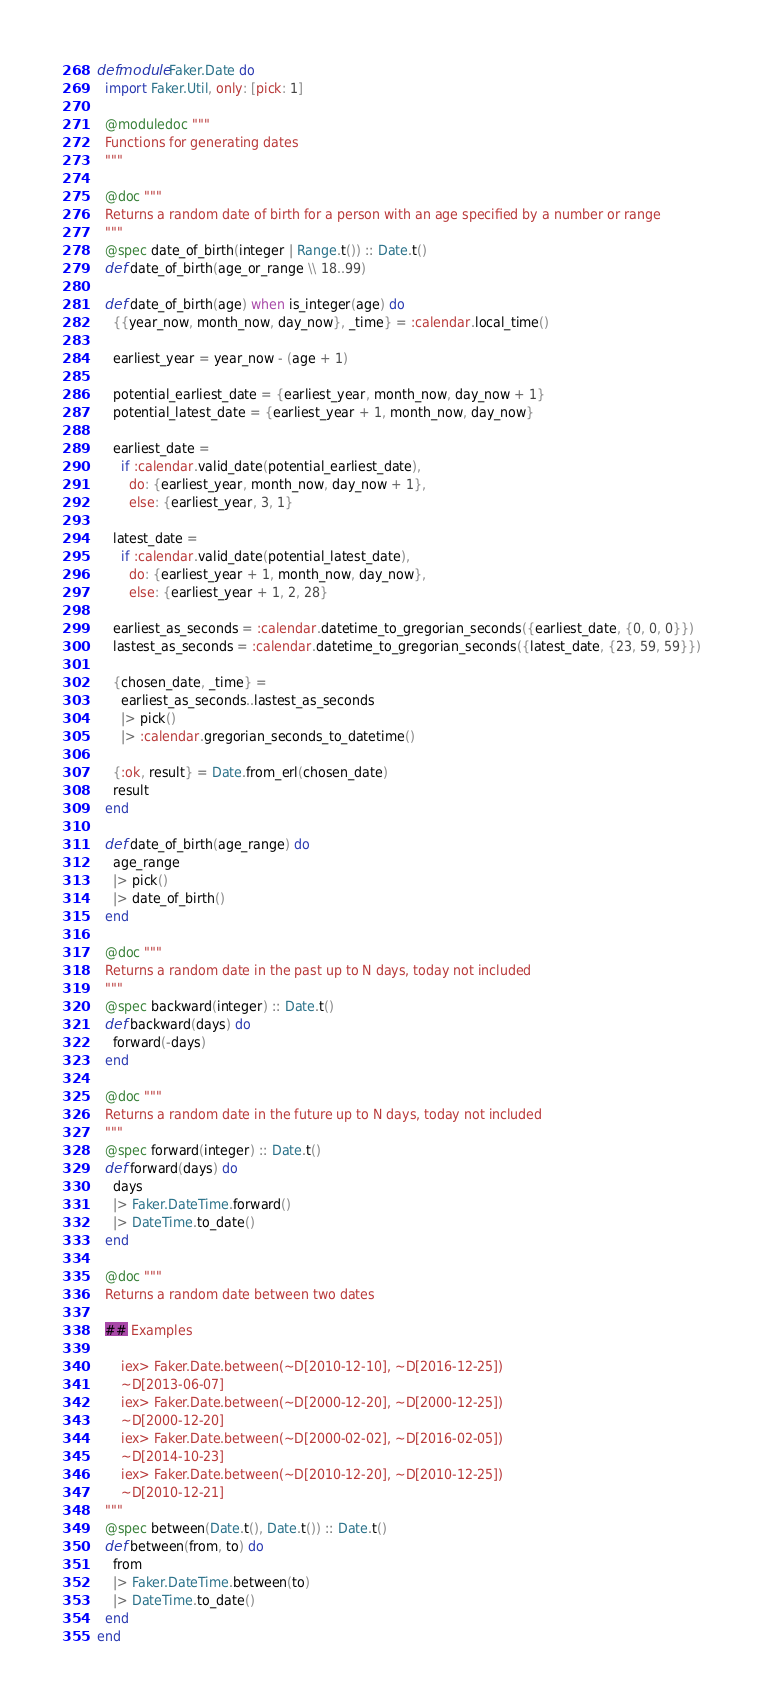Convert code to text. <code><loc_0><loc_0><loc_500><loc_500><_Elixir_>defmodule Faker.Date do
  import Faker.Util, only: [pick: 1]

  @moduledoc """
  Functions for generating dates
  """

  @doc """
  Returns a random date of birth for a person with an age specified by a number or range
  """
  @spec date_of_birth(integer | Range.t()) :: Date.t()
  def date_of_birth(age_or_range \\ 18..99)

  def date_of_birth(age) when is_integer(age) do
    {{year_now, month_now, day_now}, _time} = :calendar.local_time()

    earliest_year = year_now - (age + 1)

    potential_earliest_date = {earliest_year, month_now, day_now + 1}
    potential_latest_date = {earliest_year + 1, month_now, day_now}

    earliest_date =
      if :calendar.valid_date(potential_earliest_date),
        do: {earliest_year, month_now, day_now + 1},
        else: {earliest_year, 3, 1}

    latest_date =
      if :calendar.valid_date(potential_latest_date),
        do: {earliest_year + 1, month_now, day_now},
        else: {earliest_year + 1, 2, 28}

    earliest_as_seconds = :calendar.datetime_to_gregorian_seconds({earliest_date, {0, 0, 0}})
    lastest_as_seconds = :calendar.datetime_to_gregorian_seconds({latest_date, {23, 59, 59}})

    {chosen_date, _time} =
      earliest_as_seconds..lastest_as_seconds
      |> pick()
      |> :calendar.gregorian_seconds_to_datetime()

    {:ok, result} = Date.from_erl(chosen_date)
    result
  end

  def date_of_birth(age_range) do
    age_range
    |> pick()
    |> date_of_birth()
  end

  @doc """
  Returns a random date in the past up to N days, today not included
  """
  @spec backward(integer) :: Date.t()
  def backward(days) do
    forward(-days)
  end

  @doc """
  Returns a random date in the future up to N days, today not included
  """
  @spec forward(integer) :: Date.t()
  def forward(days) do
    days
    |> Faker.DateTime.forward()
    |> DateTime.to_date()
  end

  @doc """
  Returns a random date between two dates

  ## Examples

      iex> Faker.Date.between(~D[2010-12-10], ~D[2016-12-25])
      ~D[2013-06-07]
      iex> Faker.Date.between(~D[2000-12-20], ~D[2000-12-25])
      ~D[2000-12-20]
      iex> Faker.Date.between(~D[2000-02-02], ~D[2016-02-05])
      ~D[2014-10-23]
      iex> Faker.Date.between(~D[2010-12-20], ~D[2010-12-25])
      ~D[2010-12-21]
  """
  @spec between(Date.t(), Date.t()) :: Date.t()
  def between(from, to) do
    from
    |> Faker.DateTime.between(to)
    |> DateTime.to_date()
  end
end
</code> 